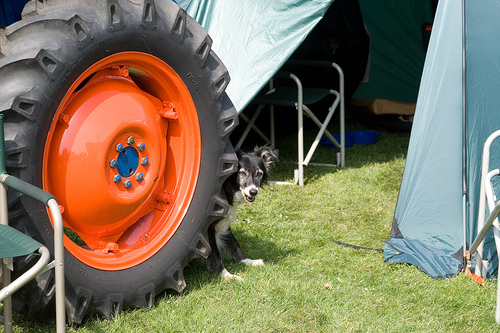<image>
Is there a cog in the wheel? Yes. The cog is contained within or inside the wheel, showing a containment relationship. Is there a dog behind the tire? Yes. From this viewpoint, the dog is positioned behind the tire, with the tire partially or fully occluding the dog. Is the tire behind the dog? No. The tire is not behind the dog. From this viewpoint, the tire appears to be positioned elsewhere in the scene. Is the grass on the dog? No. The grass is not positioned on the dog. They may be near each other, but the grass is not supported by or resting on top of the dog. 